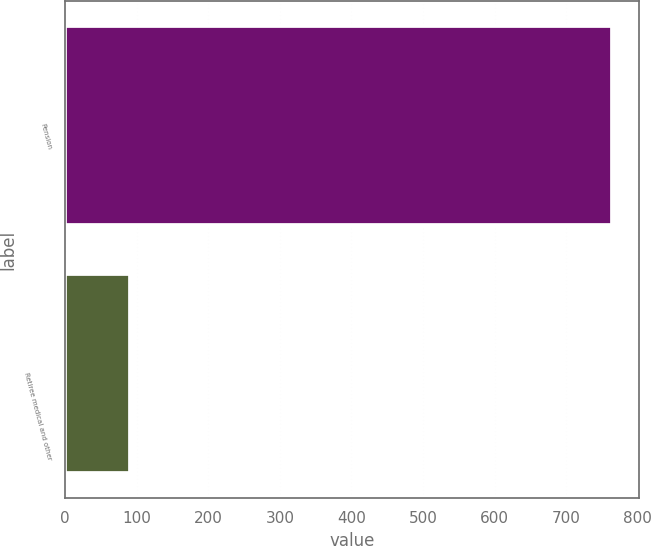<chart> <loc_0><loc_0><loc_500><loc_500><bar_chart><fcel>Pension<fcel>Retiree medical and other<nl><fcel>764<fcel>90<nl></chart> 